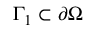<formula> <loc_0><loc_0><loc_500><loc_500>\Gamma _ { 1 } \subset \partial \Omega</formula> 